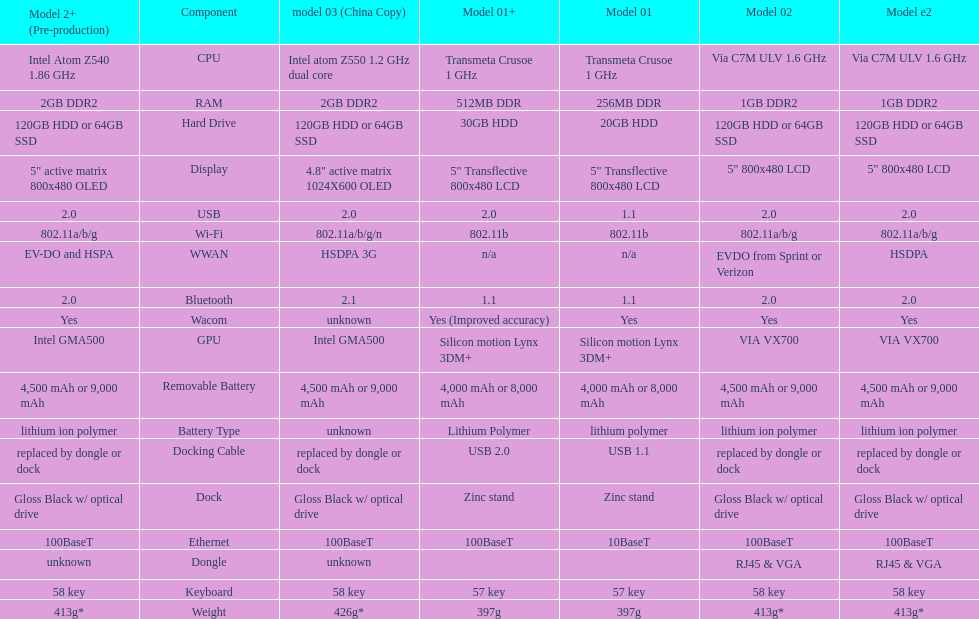I'm looking to parse the entire table for insights. Could you assist me with that? {'header': ['Model 2+ (Pre-production)', 'Component', 'model 03 (China Copy)', 'Model 01+', 'Model 01', 'Model 02', 'Model e2'], 'rows': [['Intel Atom Z540 1.86\xa0GHz', 'CPU', 'Intel atom Z550 1.2\xa0GHz dual core', 'Transmeta Crusoe 1\xa0GHz', 'Transmeta Crusoe 1\xa0GHz', 'Via C7M ULV 1.6\xa0GHz', 'Via C7M ULV 1.6\xa0GHz'], ['2GB DDR2', 'RAM', '2GB DDR2', '512MB DDR', '256MB DDR', '1GB DDR2', '1GB DDR2'], ['120GB HDD or 64GB SSD', 'Hard Drive', '120GB HDD or 64GB SSD', '30GB HDD', '20GB HDD', '120GB HDD or 64GB SSD', '120GB HDD or 64GB SSD'], ['5" active matrix 800x480 OLED', 'Display', '4.8" active matrix 1024X600 OLED', '5" Transflective 800x480 LCD', '5" Transflective 800x480 LCD', '5" 800x480 LCD', '5" 800x480 LCD'], ['2.0', 'USB', '2.0', '2.0', '1.1', '2.0', '2.0'], ['802.11a/b/g', 'Wi-Fi', '802.11a/b/g/n', '802.11b', '802.11b', '802.11a/b/g', '802.11a/b/g'], ['EV-DO and HSPA', 'WWAN', 'HSDPA 3G', 'n/a', 'n/a', 'EVDO from Sprint or Verizon', 'HSDPA'], ['2.0', 'Bluetooth', '2.1', '1.1', '1.1', '2.0', '2.0'], ['Yes', 'Wacom', 'unknown', 'Yes (Improved accuracy)', 'Yes', 'Yes', 'Yes'], ['Intel GMA500', 'GPU', 'Intel GMA500', 'Silicon motion Lynx 3DM+', 'Silicon motion Lynx 3DM+', 'VIA VX700', 'VIA VX700'], ['4,500 mAh or 9,000 mAh', 'Removable Battery', '4,500 mAh or 9,000 mAh', '4,000 mAh or 8,000 mAh', '4,000 mAh or 8,000 mAh', '4,500 mAh or 9,000 mAh', '4,500 mAh or 9,000 mAh'], ['lithium ion polymer', 'Battery Type', 'unknown', 'Lithium Polymer', 'lithium polymer', 'lithium ion polymer', 'lithium ion polymer'], ['replaced by dongle or dock', 'Docking Cable', 'replaced by dongle or dock', 'USB 2.0', 'USB 1.1', 'replaced by dongle or dock', 'replaced by dongle or dock'], ['Gloss Black w/ optical drive', 'Dock', 'Gloss Black w/ optical drive', 'Zinc stand', 'Zinc stand', 'Gloss Black w/ optical drive', 'Gloss Black w/ optical drive'], ['100BaseT', 'Ethernet', '100BaseT', '100BaseT', '10BaseT', '100BaseT', '100BaseT'], ['unknown', 'Dongle', 'unknown', '', '', 'RJ45 & VGA', 'RJ45 & VGA'], ['58 key', 'Keyboard', '58 key', '57 key', '57 key', '58 key', '58 key'], ['413g*', 'Weight', '426g*', '397g', '397g', '413g*', '413g*']]} How many models use a usb docking cable? 2. 